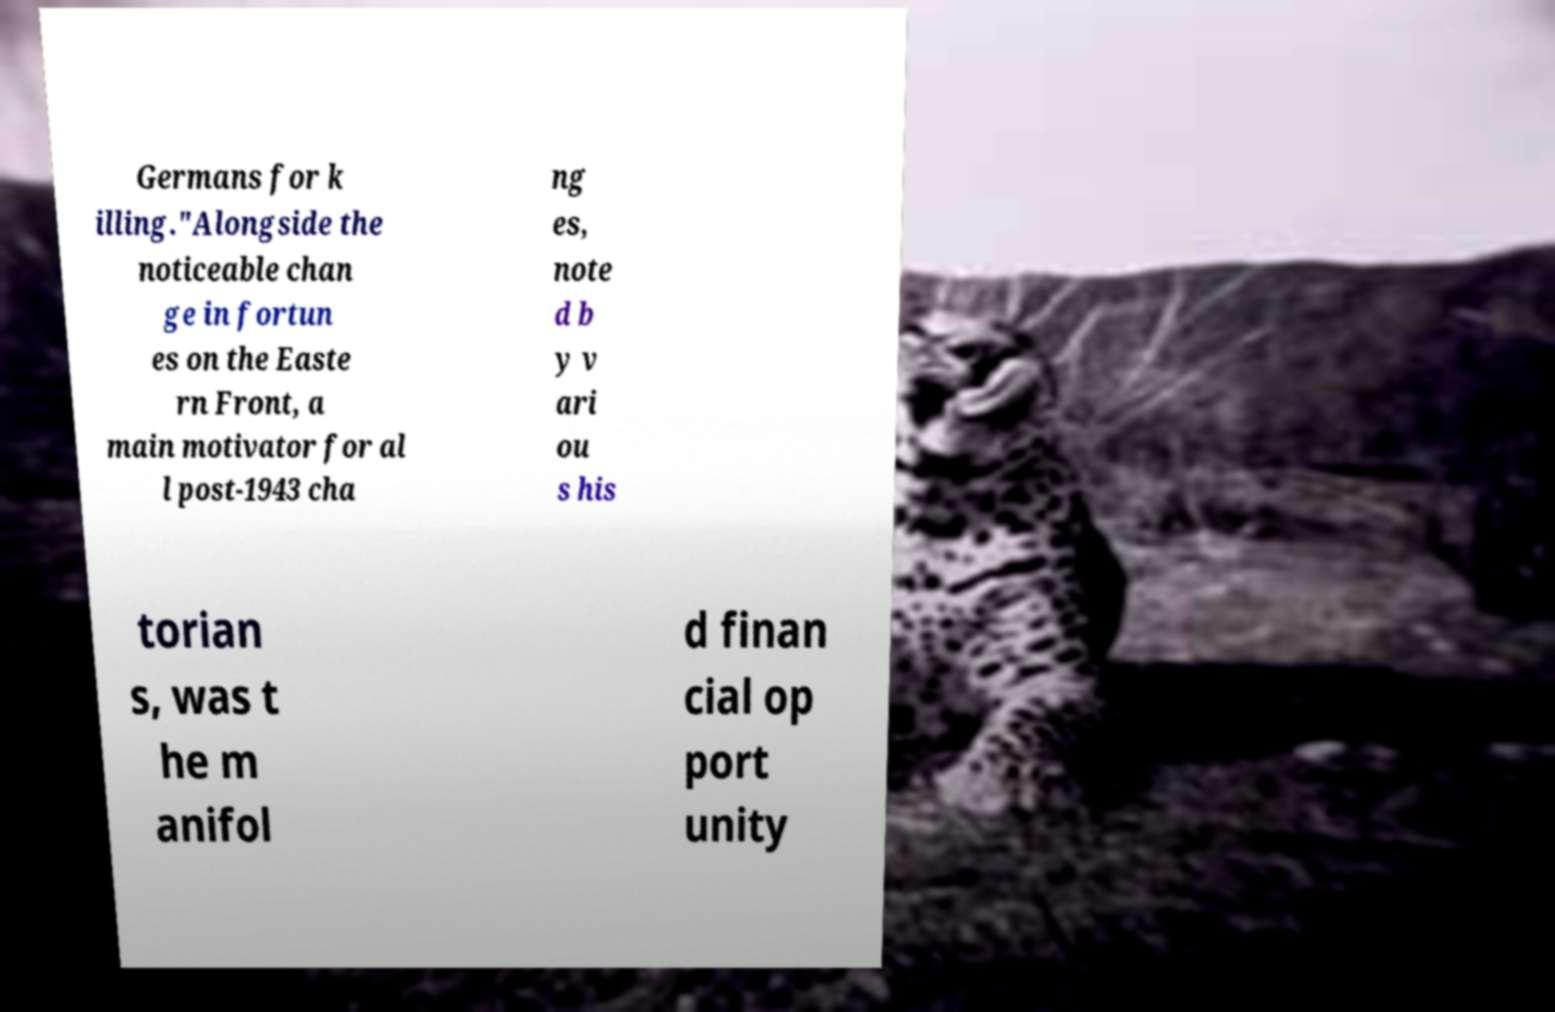Can you accurately transcribe the text from the provided image for me? Germans for k illing."Alongside the noticeable chan ge in fortun es on the Easte rn Front, a main motivator for al l post-1943 cha ng es, note d b y v ari ou s his torian s, was t he m anifol d finan cial op port unity 